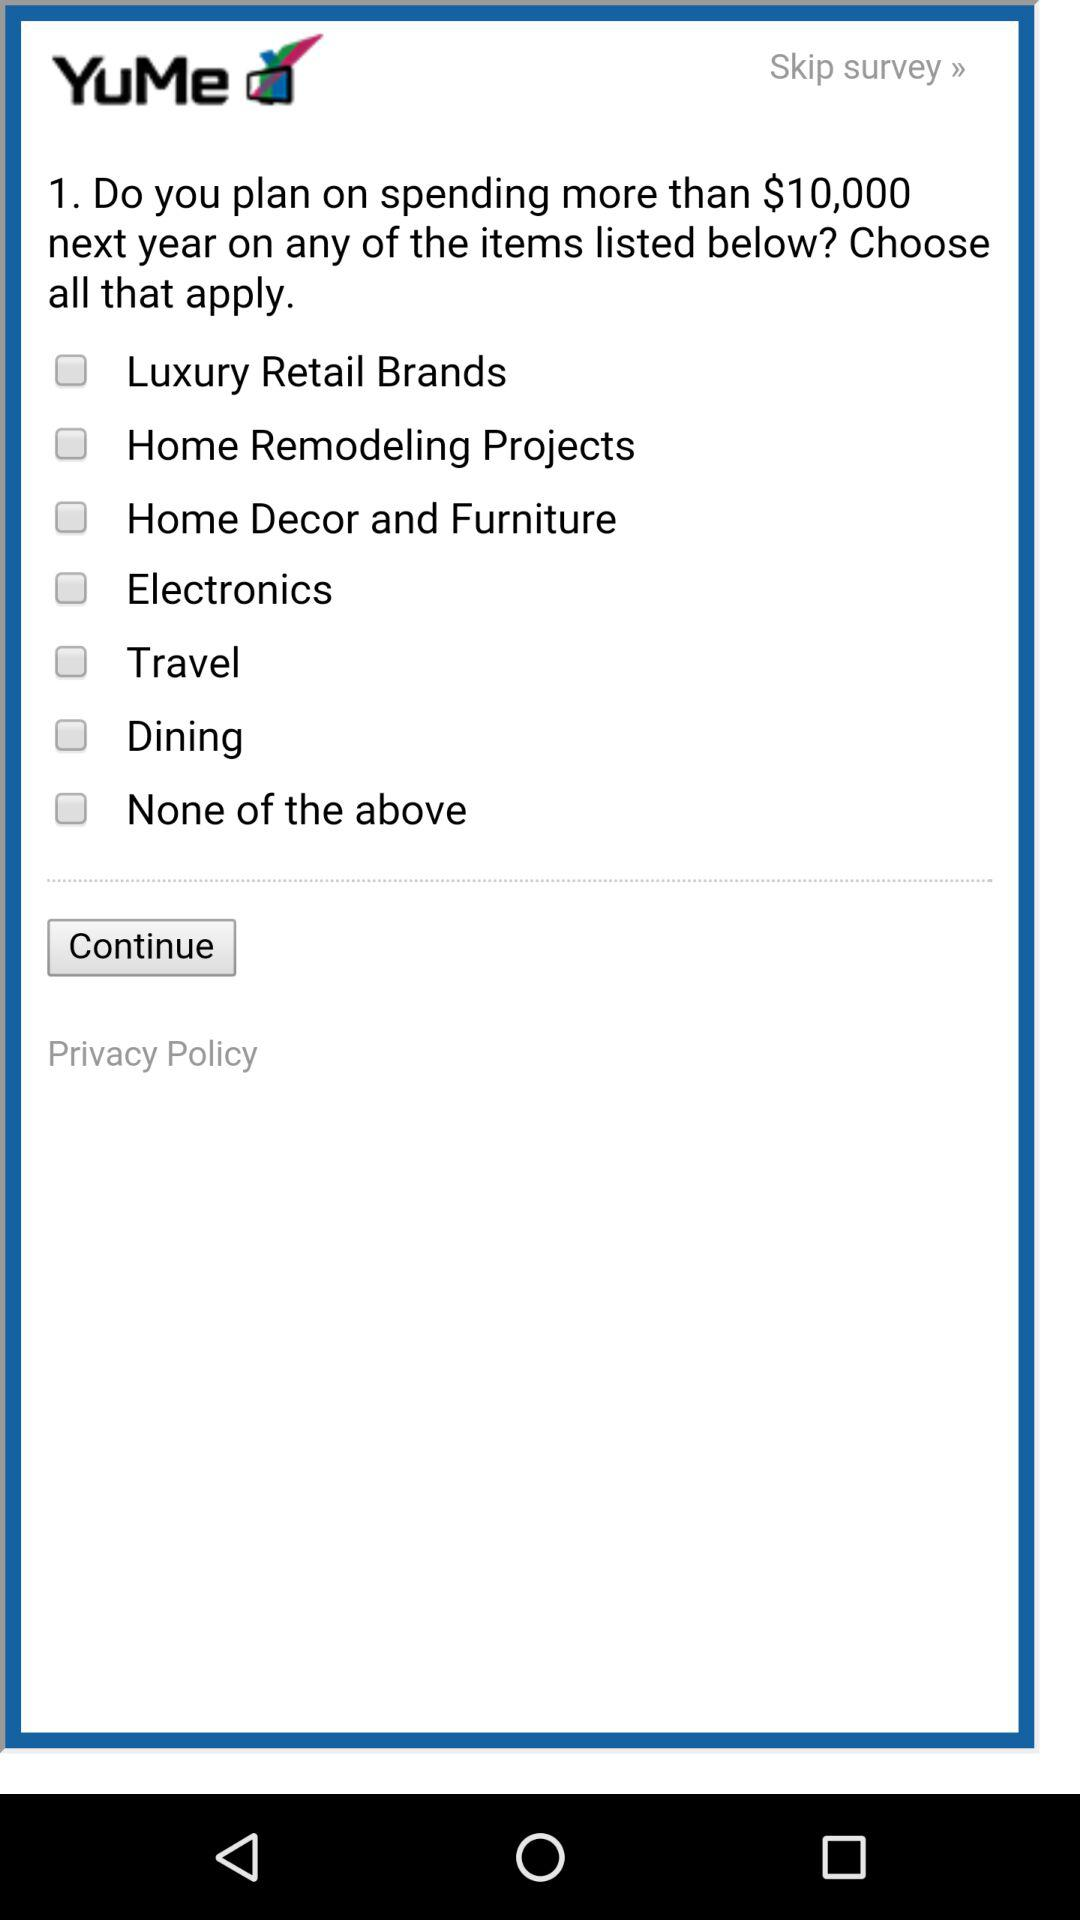What is the status of "Travel"? The status of "Travel" is "off". 